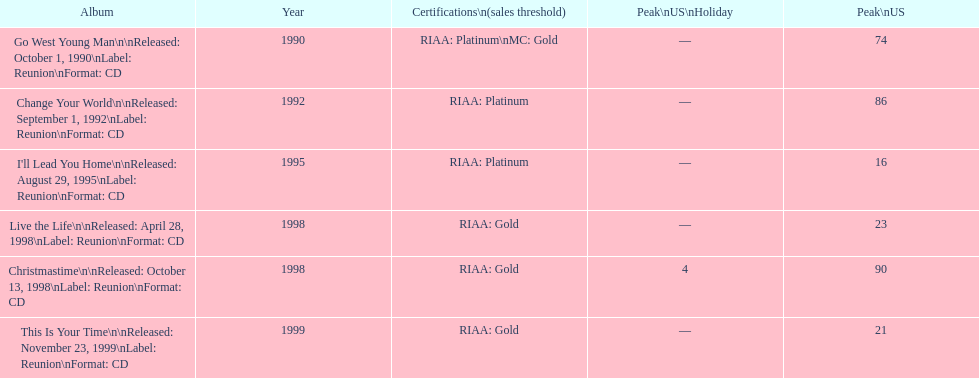Give me the full table as a dictionary. {'header': ['Album', 'Year', 'Certifications\\n(sales threshold)', 'Peak\\nUS\\nHoliday', 'Peak\\nUS'], 'rows': [['Go West Young Man\\n\\nReleased: October 1, 1990\\nLabel: Reunion\\nFormat: CD', '1990', 'RIAA: Platinum\\nMC: Gold', '—', '74'], ['Change Your World\\n\\nReleased: September 1, 1992\\nLabel: Reunion\\nFormat: CD', '1992', 'RIAA: Platinum', '—', '86'], ["I'll Lead You Home\\n\\nReleased: August 29, 1995\\nLabel: Reunion\\nFormat: CD", '1995', 'RIAA: Platinum', '—', '16'], ['Live the Life\\n\\nReleased: April 28, 1998\\nLabel: Reunion\\nFormat: CD', '1998', 'RIAA: Gold', '—', '23'], ['Christmastime\\n\\nReleased: October 13, 1998\\nLabel: Reunion\\nFormat: CD', '1998', 'RIAA: Gold', '4', '90'], ['This Is Your Time\\n\\nReleased: November 23, 1999\\nLabel: Reunion\\nFormat: CD', '1999', 'RIAA: Gold', '—', '21']]} How many album entries are there? 6. 